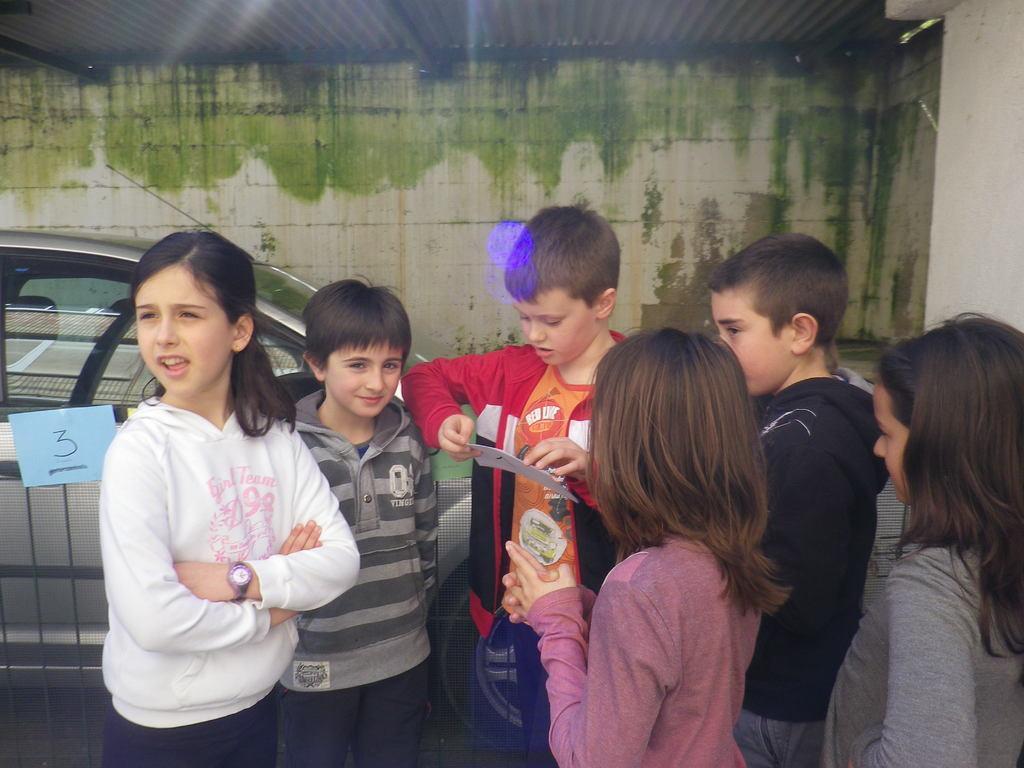Could you give a brief overview of what you see in this image? In this picture we can see a group of children standing on the ground, car and in the background we can see wall. 